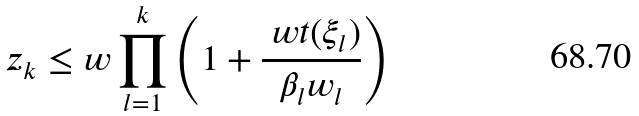Convert formula to latex. <formula><loc_0><loc_0><loc_500><loc_500>z _ { k } \leq w \prod _ { l = 1 } ^ { k } \left ( 1 + \frac { \ w t ( \xi _ { l } ) } { \beta _ { l } w _ { l } } \right )</formula> 